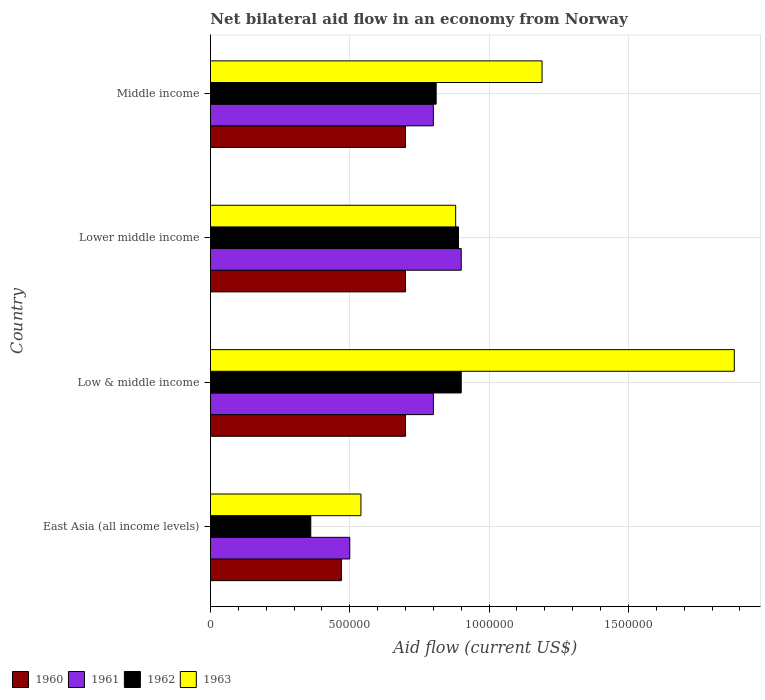How many different coloured bars are there?
Offer a very short reply. 4. How many groups of bars are there?
Your response must be concise. 4. Are the number of bars per tick equal to the number of legend labels?
Your answer should be compact. Yes. Are the number of bars on each tick of the Y-axis equal?
Your answer should be compact. Yes. How many bars are there on the 4th tick from the top?
Make the answer very short. 4. In how many cases, is the number of bars for a given country not equal to the number of legend labels?
Make the answer very short. 0. What is the net bilateral aid flow in 1960 in Low & middle income?
Provide a succinct answer. 7.00e+05. Across all countries, what is the maximum net bilateral aid flow in 1960?
Your answer should be very brief. 7.00e+05. In which country was the net bilateral aid flow in 1963 minimum?
Your answer should be compact. East Asia (all income levels). What is the total net bilateral aid flow in 1963 in the graph?
Make the answer very short. 4.49e+06. What is the difference between the net bilateral aid flow in 1963 in East Asia (all income levels) and that in Low & middle income?
Provide a succinct answer. -1.34e+06. What is the difference between the net bilateral aid flow in 1963 in Lower middle income and the net bilateral aid flow in 1962 in Low & middle income?
Offer a very short reply. -2.00e+04. What is the average net bilateral aid flow in 1963 per country?
Offer a terse response. 1.12e+06. What is the difference between the net bilateral aid flow in 1960 and net bilateral aid flow in 1963 in Middle income?
Keep it short and to the point. -4.90e+05. Is the net bilateral aid flow in 1961 in Lower middle income less than that in Middle income?
Make the answer very short. No. What is the difference between the highest and the second highest net bilateral aid flow in 1961?
Make the answer very short. 1.00e+05. What is the difference between the highest and the lowest net bilateral aid flow in 1963?
Give a very brief answer. 1.34e+06. In how many countries, is the net bilateral aid flow in 1961 greater than the average net bilateral aid flow in 1961 taken over all countries?
Provide a short and direct response. 3. Is the sum of the net bilateral aid flow in 1961 in Low & middle income and Lower middle income greater than the maximum net bilateral aid flow in 1960 across all countries?
Your answer should be compact. Yes. Is it the case that in every country, the sum of the net bilateral aid flow in 1960 and net bilateral aid flow in 1963 is greater than the sum of net bilateral aid flow in 1961 and net bilateral aid flow in 1962?
Your answer should be very brief. No. What does the 3rd bar from the bottom in Low & middle income represents?
Offer a terse response. 1962. Are all the bars in the graph horizontal?
Provide a short and direct response. Yes. How many countries are there in the graph?
Ensure brevity in your answer.  4. Where does the legend appear in the graph?
Make the answer very short. Bottom left. How many legend labels are there?
Keep it short and to the point. 4. How are the legend labels stacked?
Make the answer very short. Horizontal. What is the title of the graph?
Provide a succinct answer. Net bilateral aid flow in an economy from Norway. What is the Aid flow (current US$) of 1961 in East Asia (all income levels)?
Your response must be concise. 5.00e+05. What is the Aid flow (current US$) of 1962 in East Asia (all income levels)?
Offer a very short reply. 3.60e+05. What is the Aid flow (current US$) in 1963 in East Asia (all income levels)?
Make the answer very short. 5.40e+05. What is the Aid flow (current US$) in 1963 in Low & middle income?
Your answer should be very brief. 1.88e+06. What is the Aid flow (current US$) in 1960 in Lower middle income?
Give a very brief answer. 7.00e+05. What is the Aid flow (current US$) of 1961 in Lower middle income?
Make the answer very short. 9.00e+05. What is the Aid flow (current US$) of 1962 in Lower middle income?
Provide a succinct answer. 8.90e+05. What is the Aid flow (current US$) in 1963 in Lower middle income?
Your answer should be very brief. 8.80e+05. What is the Aid flow (current US$) of 1960 in Middle income?
Offer a terse response. 7.00e+05. What is the Aid flow (current US$) in 1961 in Middle income?
Provide a succinct answer. 8.00e+05. What is the Aid flow (current US$) of 1962 in Middle income?
Provide a short and direct response. 8.10e+05. What is the Aid flow (current US$) of 1963 in Middle income?
Offer a terse response. 1.19e+06. Across all countries, what is the maximum Aid flow (current US$) of 1963?
Offer a terse response. 1.88e+06. Across all countries, what is the minimum Aid flow (current US$) in 1962?
Make the answer very short. 3.60e+05. Across all countries, what is the minimum Aid flow (current US$) of 1963?
Provide a succinct answer. 5.40e+05. What is the total Aid flow (current US$) of 1960 in the graph?
Your response must be concise. 2.57e+06. What is the total Aid flow (current US$) in 1962 in the graph?
Give a very brief answer. 2.96e+06. What is the total Aid flow (current US$) in 1963 in the graph?
Your answer should be compact. 4.49e+06. What is the difference between the Aid flow (current US$) of 1961 in East Asia (all income levels) and that in Low & middle income?
Your answer should be compact. -3.00e+05. What is the difference between the Aid flow (current US$) in 1962 in East Asia (all income levels) and that in Low & middle income?
Provide a succinct answer. -5.40e+05. What is the difference between the Aid flow (current US$) of 1963 in East Asia (all income levels) and that in Low & middle income?
Your answer should be compact. -1.34e+06. What is the difference between the Aid flow (current US$) in 1960 in East Asia (all income levels) and that in Lower middle income?
Your response must be concise. -2.30e+05. What is the difference between the Aid flow (current US$) in 1961 in East Asia (all income levels) and that in Lower middle income?
Provide a short and direct response. -4.00e+05. What is the difference between the Aid flow (current US$) of 1962 in East Asia (all income levels) and that in Lower middle income?
Keep it short and to the point. -5.30e+05. What is the difference between the Aid flow (current US$) of 1960 in East Asia (all income levels) and that in Middle income?
Offer a very short reply. -2.30e+05. What is the difference between the Aid flow (current US$) of 1961 in East Asia (all income levels) and that in Middle income?
Offer a very short reply. -3.00e+05. What is the difference between the Aid flow (current US$) of 1962 in East Asia (all income levels) and that in Middle income?
Your answer should be compact. -4.50e+05. What is the difference between the Aid flow (current US$) of 1963 in East Asia (all income levels) and that in Middle income?
Offer a very short reply. -6.50e+05. What is the difference between the Aid flow (current US$) in 1960 in Low & middle income and that in Lower middle income?
Give a very brief answer. 0. What is the difference between the Aid flow (current US$) of 1961 in Low & middle income and that in Lower middle income?
Your answer should be very brief. -1.00e+05. What is the difference between the Aid flow (current US$) of 1963 in Low & middle income and that in Lower middle income?
Ensure brevity in your answer.  1.00e+06. What is the difference between the Aid flow (current US$) of 1960 in Low & middle income and that in Middle income?
Give a very brief answer. 0. What is the difference between the Aid flow (current US$) in 1961 in Low & middle income and that in Middle income?
Your answer should be very brief. 0. What is the difference between the Aid flow (current US$) of 1963 in Low & middle income and that in Middle income?
Ensure brevity in your answer.  6.90e+05. What is the difference between the Aid flow (current US$) in 1962 in Lower middle income and that in Middle income?
Make the answer very short. 8.00e+04. What is the difference between the Aid flow (current US$) of 1963 in Lower middle income and that in Middle income?
Provide a succinct answer. -3.10e+05. What is the difference between the Aid flow (current US$) of 1960 in East Asia (all income levels) and the Aid flow (current US$) of 1961 in Low & middle income?
Keep it short and to the point. -3.30e+05. What is the difference between the Aid flow (current US$) in 1960 in East Asia (all income levels) and the Aid flow (current US$) in 1962 in Low & middle income?
Provide a short and direct response. -4.30e+05. What is the difference between the Aid flow (current US$) in 1960 in East Asia (all income levels) and the Aid flow (current US$) in 1963 in Low & middle income?
Provide a short and direct response. -1.41e+06. What is the difference between the Aid flow (current US$) in 1961 in East Asia (all income levels) and the Aid flow (current US$) in 1962 in Low & middle income?
Offer a very short reply. -4.00e+05. What is the difference between the Aid flow (current US$) in 1961 in East Asia (all income levels) and the Aid flow (current US$) in 1963 in Low & middle income?
Offer a very short reply. -1.38e+06. What is the difference between the Aid flow (current US$) in 1962 in East Asia (all income levels) and the Aid flow (current US$) in 1963 in Low & middle income?
Offer a terse response. -1.52e+06. What is the difference between the Aid flow (current US$) in 1960 in East Asia (all income levels) and the Aid flow (current US$) in 1961 in Lower middle income?
Offer a terse response. -4.30e+05. What is the difference between the Aid flow (current US$) of 1960 in East Asia (all income levels) and the Aid flow (current US$) of 1962 in Lower middle income?
Ensure brevity in your answer.  -4.20e+05. What is the difference between the Aid flow (current US$) of 1960 in East Asia (all income levels) and the Aid flow (current US$) of 1963 in Lower middle income?
Provide a succinct answer. -4.10e+05. What is the difference between the Aid flow (current US$) in 1961 in East Asia (all income levels) and the Aid flow (current US$) in 1962 in Lower middle income?
Provide a short and direct response. -3.90e+05. What is the difference between the Aid flow (current US$) in 1961 in East Asia (all income levels) and the Aid flow (current US$) in 1963 in Lower middle income?
Offer a very short reply. -3.80e+05. What is the difference between the Aid flow (current US$) in 1962 in East Asia (all income levels) and the Aid flow (current US$) in 1963 in Lower middle income?
Make the answer very short. -5.20e+05. What is the difference between the Aid flow (current US$) of 1960 in East Asia (all income levels) and the Aid flow (current US$) of 1961 in Middle income?
Provide a short and direct response. -3.30e+05. What is the difference between the Aid flow (current US$) of 1960 in East Asia (all income levels) and the Aid flow (current US$) of 1962 in Middle income?
Make the answer very short. -3.40e+05. What is the difference between the Aid flow (current US$) in 1960 in East Asia (all income levels) and the Aid flow (current US$) in 1963 in Middle income?
Your response must be concise. -7.20e+05. What is the difference between the Aid flow (current US$) of 1961 in East Asia (all income levels) and the Aid flow (current US$) of 1962 in Middle income?
Your response must be concise. -3.10e+05. What is the difference between the Aid flow (current US$) of 1961 in East Asia (all income levels) and the Aid flow (current US$) of 1963 in Middle income?
Provide a succinct answer. -6.90e+05. What is the difference between the Aid flow (current US$) of 1962 in East Asia (all income levels) and the Aid flow (current US$) of 1963 in Middle income?
Provide a short and direct response. -8.30e+05. What is the difference between the Aid flow (current US$) of 1960 in Low & middle income and the Aid flow (current US$) of 1963 in Lower middle income?
Offer a very short reply. -1.80e+05. What is the difference between the Aid flow (current US$) of 1961 in Low & middle income and the Aid flow (current US$) of 1962 in Lower middle income?
Provide a short and direct response. -9.00e+04. What is the difference between the Aid flow (current US$) in 1961 in Low & middle income and the Aid flow (current US$) in 1963 in Lower middle income?
Keep it short and to the point. -8.00e+04. What is the difference between the Aid flow (current US$) in 1962 in Low & middle income and the Aid flow (current US$) in 1963 in Lower middle income?
Give a very brief answer. 2.00e+04. What is the difference between the Aid flow (current US$) of 1960 in Low & middle income and the Aid flow (current US$) of 1961 in Middle income?
Provide a short and direct response. -1.00e+05. What is the difference between the Aid flow (current US$) of 1960 in Low & middle income and the Aid flow (current US$) of 1962 in Middle income?
Ensure brevity in your answer.  -1.10e+05. What is the difference between the Aid flow (current US$) in 1960 in Low & middle income and the Aid flow (current US$) in 1963 in Middle income?
Ensure brevity in your answer.  -4.90e+05. What is the difference between the Aid flow (current US$) of 1961 in Low & middle income and the Aid flow (current US$) of 1963 in Middle income?
Your answer should be very brief. -3.90e+05. What is the difference between the Aid flow (current US$) in 1960 in Lower middle income and the Aid flow (current US$) in 1963 in Middle income?
Give a very brief answer. -4.90e+05. What is the difference between the Aid flow (current US$) of 1961 in Lower middle income and the Aid flow (current US$) of 1962 in Middle income?
Make the answer very short. 9.00e+04. What is the difference between the Aid flow (current US$) of 1961 in Lower middle income and the Aid flow (current US$) of 1963 in Middle income?
Give a very brief answer. -2.90e+05. What is the difference between the Aid flow (current US$) of 1962 in Lower middle income and the Aid flow (current US$) of 1963 in Middle income?
Your answer should be compact. -3.00e+05. What is the average Aid flow (current US$) of 1960 per country?
Keep it short and to the point. 6.42e+05. What is the average Aid flow (current US$) of 1961 per country?
Your response must be concise. 7.50e+05. What is the average Aid flow (current US$) of 1962 per country?
Your response must be concise. 7.40e+05. What is the average Aid flow (current US$) of 1963 per country?
Your answer should be compact. 1.12e+06. What is the difference between the Aid flow (current US$) in 1960 and Aid flow (current US$) in 1961 in East Asia (all income levels)?
Offer a terse response. -3.00e+04. What is the difference between the Aid flow (current US$) in 1961 and Aid flow (current US$) in 1962 in East Asia (all income levels)?
Offer a terse response. 1.40e+05. What is the difference between the Aid flow (current US$) of 1962 and Aid flow (current US$) of 1963 in East Asia (all income levels)?
Ensure brevity in your answer.  -1.80e+05. What is the difference between the Aid flow (current US$) in 1960 and Aid flow (current US$) in 1961 in Low & middle income?
Give a very brief answer. -1.00e+05. What is the difference between the Aid flow (current US$) in 1960 and Aid flow (current US$) in 1962 in Low & middle income?
Provide a short and direct response. -2.00e+05. What is the difference between the Aid flow (current US$) of 1960 and Aid flow (current US$) of 1963 in Low & middle income?
Make the answer very short. -1.18e+06. What is the difference between the Aid flow (current US$) in 1961 and Aid flow (current US$) in 1963 in Low & middle income?
Ensure brevity in your answer.  -1.08e+06. What is the difference between the Aid flow (current US$) in 1962 and Aid flow (current US$) in 1963 in Low & middle income?
Provide a succinct answer. -9.80e+05. What is the difference between the Aid flow (current US$) in 1960 and Aid flow (current US$) in 1961 in Lower middle income?
Offer a terse response. -2.00e+05. What is the difference between the Aid flow (current US$) in 1960 and Aid flow (current US$) in 1962 in Lower middle income?
Keep it short and to the point. -1.90e+05. What is the difference between the Aid flow (current US$) in 1960 and Aid flow (current US$) in 1963 in Lower middle income?
Your response must be concise. -1.80e+05. What is the difference between the Aid flow (current US$) in 1961 and Aid flow (current US$) in 1962 in Lower middle income?
Offer a terse response. 10000. What is the difference between the Aid flow (current US$) in 1962 and Aid flow (current US$) in 1963 in Lower middle income?
Provide a short and direct response. 10000. What is the difference between the Aid flow (current US$) in 1960 and Aid flow (current US$) in 1961 in Middle income?
Provide a succinct answer. -1.00e+05. What is the difference between the Aid flow (current US$) of 1960 and Aid flow (current US$) of 1962 in Middle income?
Ensure brevity in your answer.  -1.10e+05. What is the difference between the Aid flow (current US$) in 1960 and Aid flow (current US$) in 1963 in Middle income?
Provide a succinct answer. -4.90e+05. What is the difference between the Aid flow (current US$) in 1961 and Aid flow (current US$) in 1962 in Middle income?
Your response must be concise. -10000. What is the difference between the Aid flow (current US$) in 1961 and Aid flow (current US$) in 1963 in Middle income?
Give a very brief answer. -3.90e+05. What is the difference between the Aid flow (current US$) in 1962 and Aid flow (current US$) in 1963 in Middle income?
Keep it short and to the point. -3.80e+05. What is the ratio of the Aid flow (current US$) of 1960 in East Asia (all income levels) to that in Low & middle income?
Provide a succinct answer. 0.67. What is the ratio of the Aid flow (current US$) of 1962 in East Asia (all income levels) to that in Low & middle income?
Keep it short and to the point. 0.4. What is the ratio of the Aid flow (current US$) of 1963 in East Asia (all income levels) to that in Low & middle income?
Offer a terse response. 0.29. What is the ratio of the Aid flow (current US$) in 1960 in East Asia (all income levels) to that in Lower middle income?
Your answer should be very brief. 0.67. What is the ratio of the Aid flow (current US$) of 1961 in East Asia (all income levels) to that in Lower middle income?
Provide a succinct answer. 0.56. What is the ratio of the Aid flow (current US$) in 1962 in East Asia (all income levels) to that in Lower middle income?
Your response must be concise. 0.4. What is the ratio of the Aid flow (current US$) in 1963 in East Asia (all income levels) to that in Lower middle income?
Your answer should be compact. 0.61. What is the ratio of the Aid flow (current US$) in 1960 in East Asia (all income levels) to that in Middle income?
Your answer should be very brief. 0.67. What is the ratio of the Aid flow (current US$) in 1961 in East Asia (all income levels) to that in Middle income?
Provide a succinct answer. 0.62. What is the ratio of the Aid flow (current US$) in 1962 in East Asia (all income levels) to that in Middle income?
Provide a short and direct response. 0.44. What is the ratio of the Aid flow (current US$) in 1963 in East Asia (all income levels) to that in Middle income?
Your answer should be compact. 0.45. What is the ratio of the Aid flow (current US$) in 1961 in Low & middle income to that in Lower middle income?
Your answer should be compact. 0.89. What is the ratio of the Aid flow (current US$) in 1962 in Low & middle income to that in Lower middle income?
Provide a short and direct response. 1.01. What is the ratio of the Aid flow (current US$) of 1963 in Low & middle income to that in Lower middle income?
Provide a short and direct response. 2.14. What is the ratio of the Aid flow (current US$) of 1961 in Low & middle income to that in Middle income?
Provide a short and direct response. 1. What is the ratio of the Aid flow (current US$) of 1963 in Low & middle income to that in Middle income?
Your answer should be very brief. 1.58. What is the ratio of the Aid flow (current US$) in 1960 in Lower middle income to that in Middle income?
Your response must be concise. 1. What is the ratio of the Aid flow (current US$) in 1961 in Lower middle income to that in Middle income?
Offer a very short reply. 1.12. What is the ratio of the Aid flow (current US$) of 1962 in Lower middle income to that in Middle income?
Give a very brief answer. 1.1. What is the ratio of the Aid flow (current US$) in 1963 in Lower middle income to that in Middle income?
Your response must be concise. 0.74. What is the difference between the highest and the second highest Aid flow (current US$) in 1960?
Ensure brevity in your answer.  0. What is the difference between the highest and the second highest Aid flow (current US$) of 1962?
Provide a short and direct response. 10000. What is the difference between the highest and the second highest Aid flow (current US$) of 1963?
Provide a short and direct response. 6.90e+05. What is the difference between the highest and the lowest Aid flow (current US$) in 1961?
Provide a succinct answer. 4.00e+05. What is the difference between the highest and the lowest Aid flow (current US$) in 1962?
Make the answer very short. 5.40e+05. What is the difference between the highest and the lowest Aid flow (current US$) in 1963?
Provide a succinct answer. 1.34e+06. 